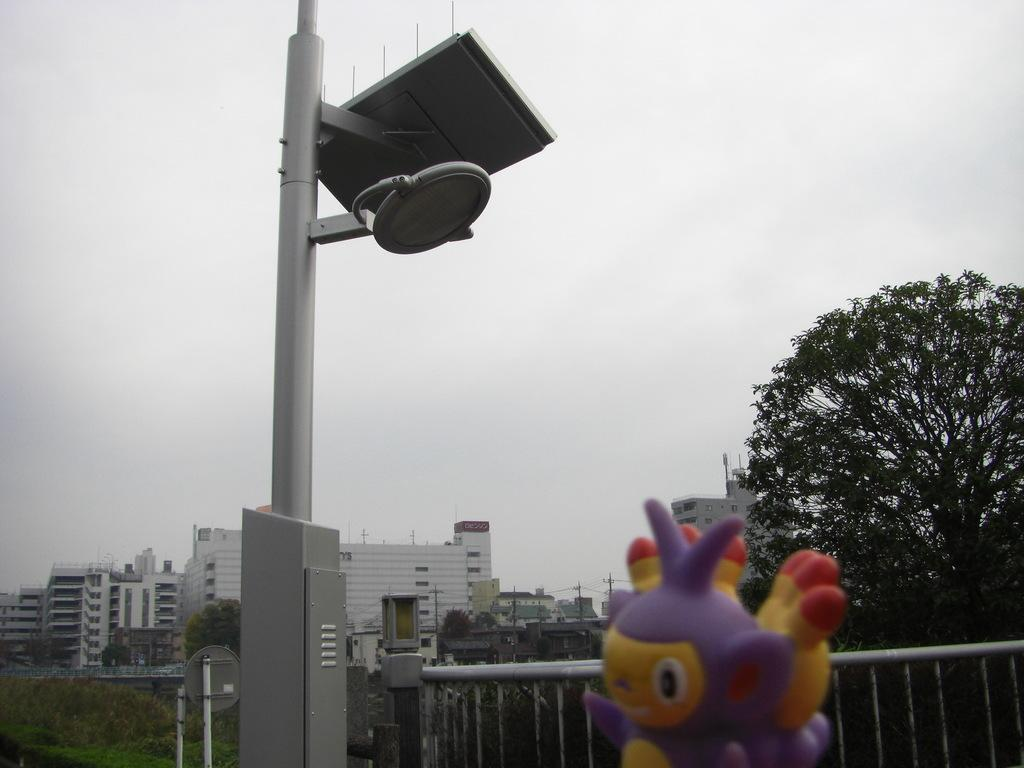What is connected to some objects in the image? There is a pole connected with some objects in the image. What can be seen near the pole? There is a railing in the image. What type of object can be seen in the image that is typically associated with play? There is a toy in the image. What can be seen in the background of the image? Trees, buildings, and the sky are visible in the background of the image. What type of memory is stored in the toy in the image? The toy in the image does not have a memory, as it is a physical object and not a device capable of storing data or information. 